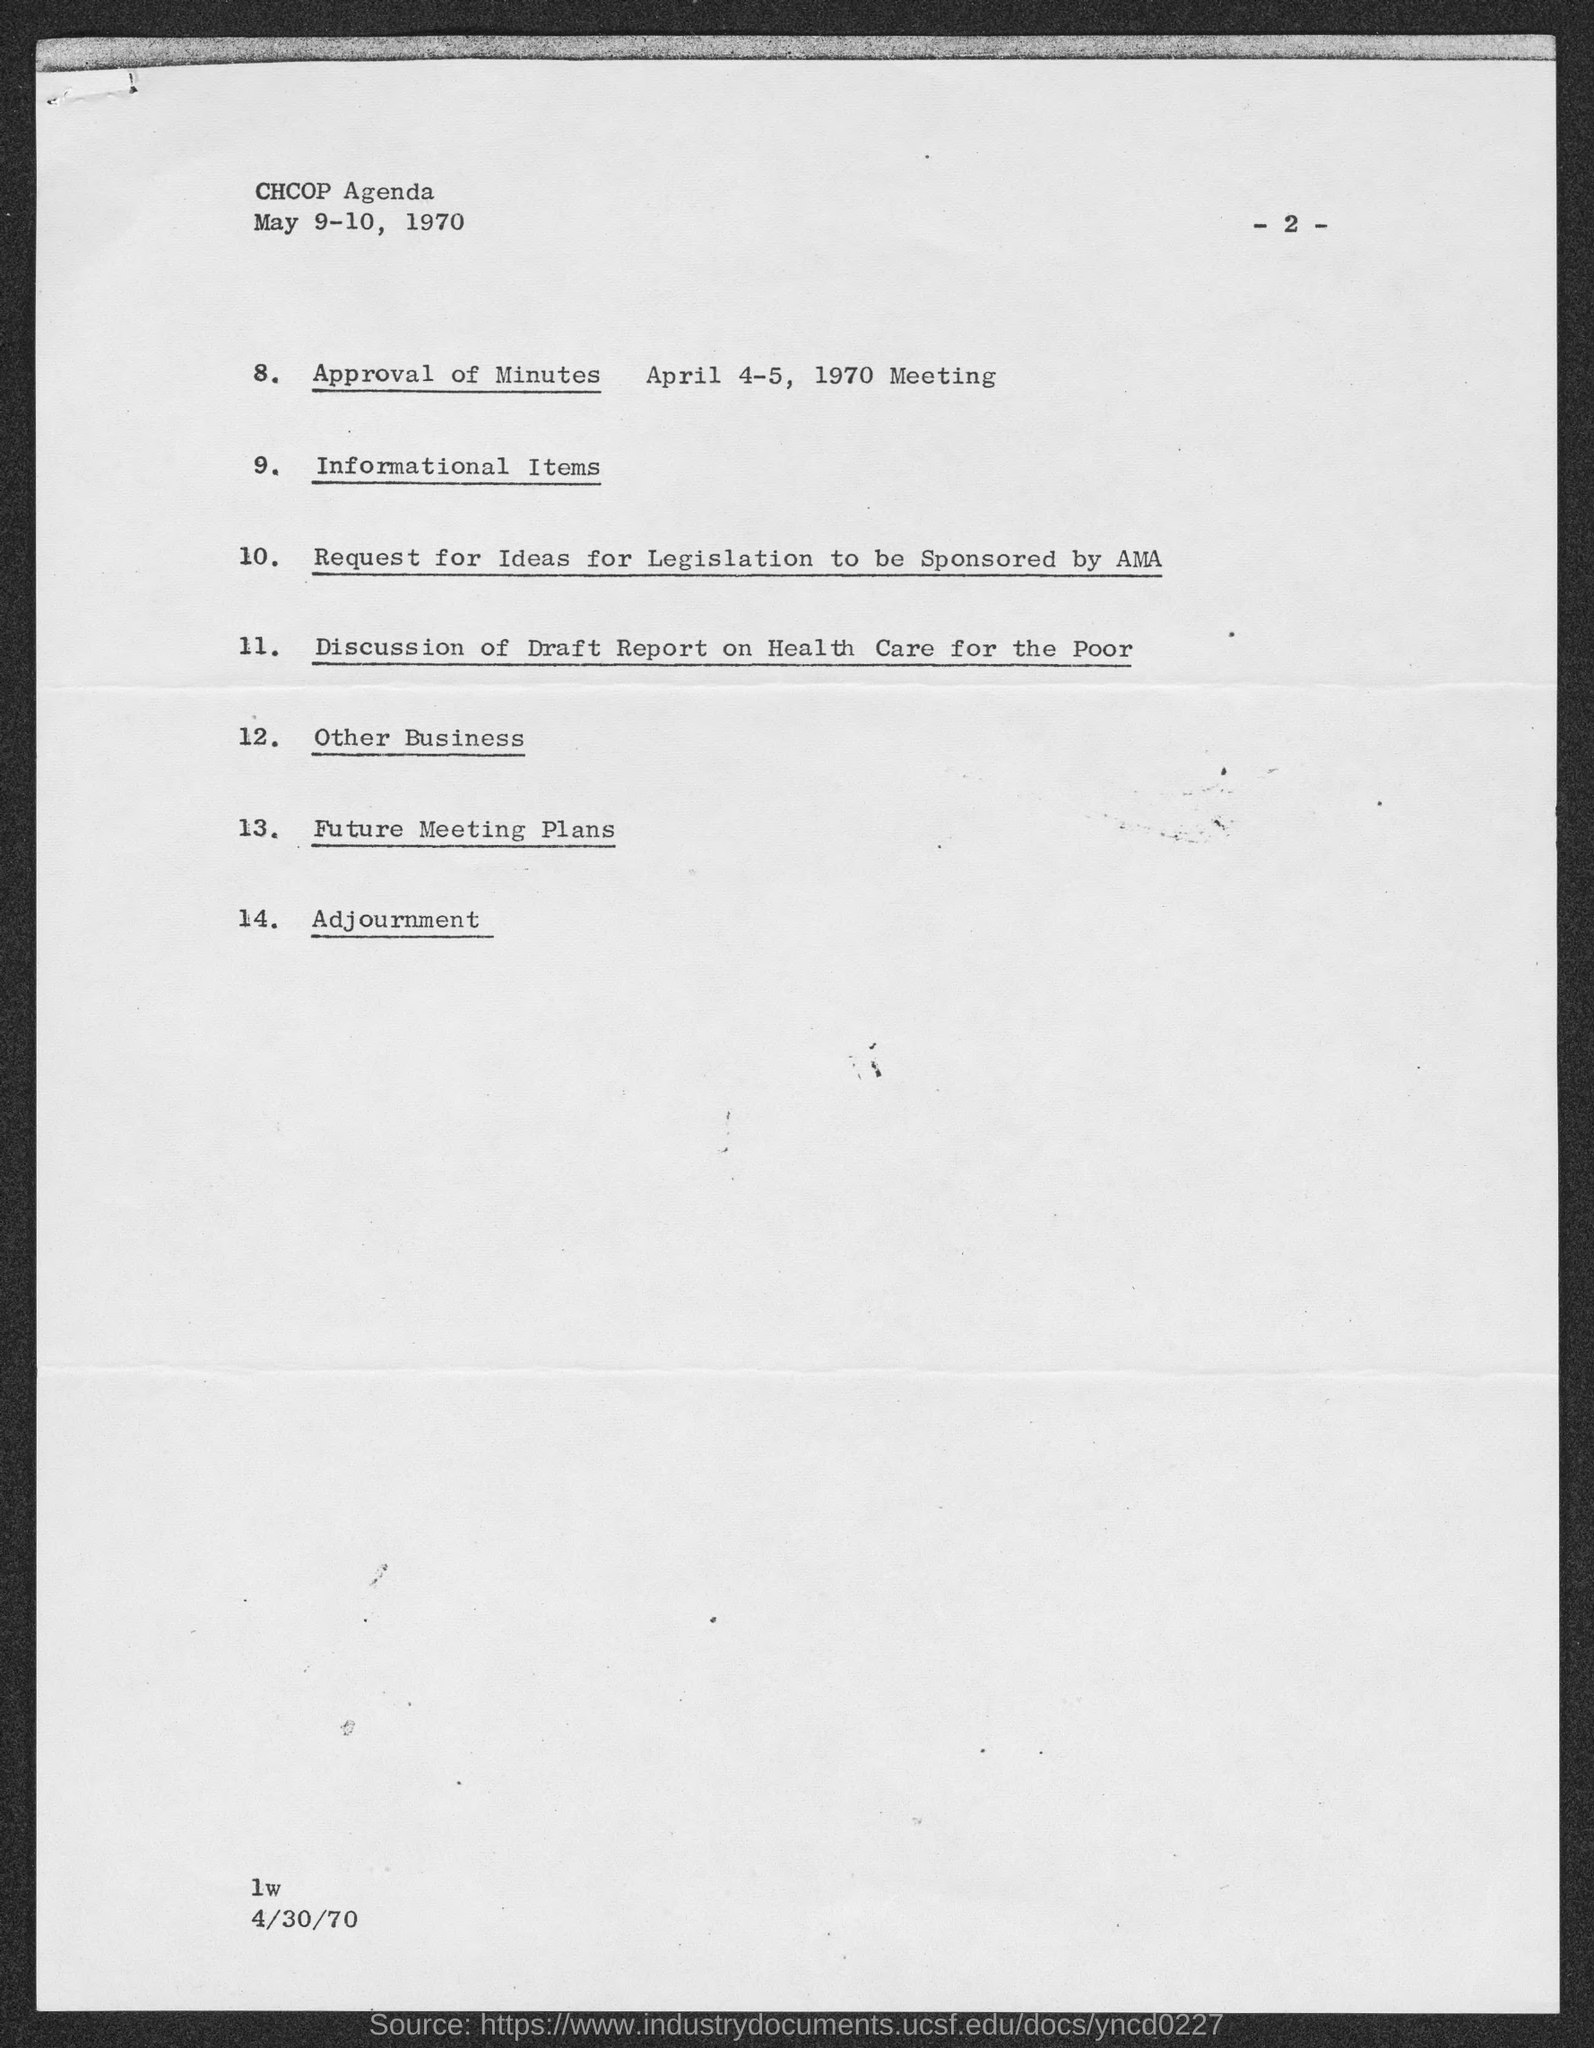Give some essential details in this illustration. The page number mentioned in this document is 2. The agenda given in the header of the document is 'ccop agenda.' 